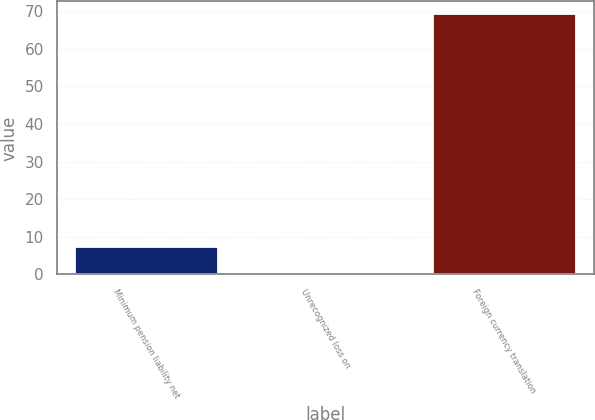Convert chart. <chart><loc_0><loc_0><loc_500><loc_500><bar_chart><fcel>Minimum pension liability net<fcel>Unrecognized loss on<fcel>Foreign currency translation<nl><fcel>7.28<fcel>0.4<fcel>69.2<nl></chart> 